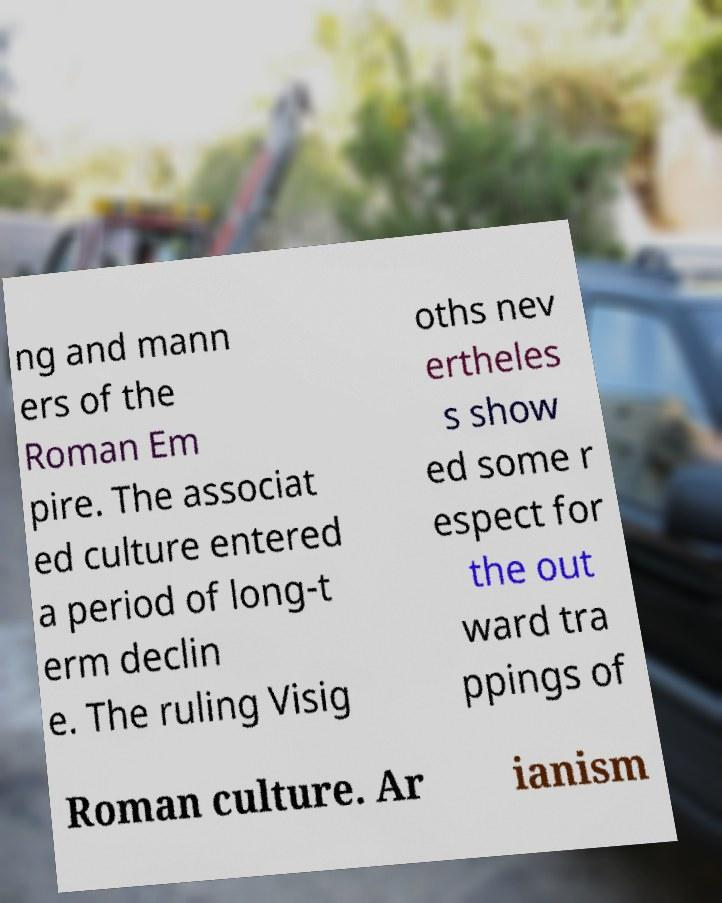Please identify and transcribe the text found in this image. ng and mann ers of the Roman Em pire. The associat ed culture entered a period of long-t erm declin e. The ruling Visig oths nev ertheles s show ed some r espect for the out ward tra ppings of Roman culture. Ar ianism 